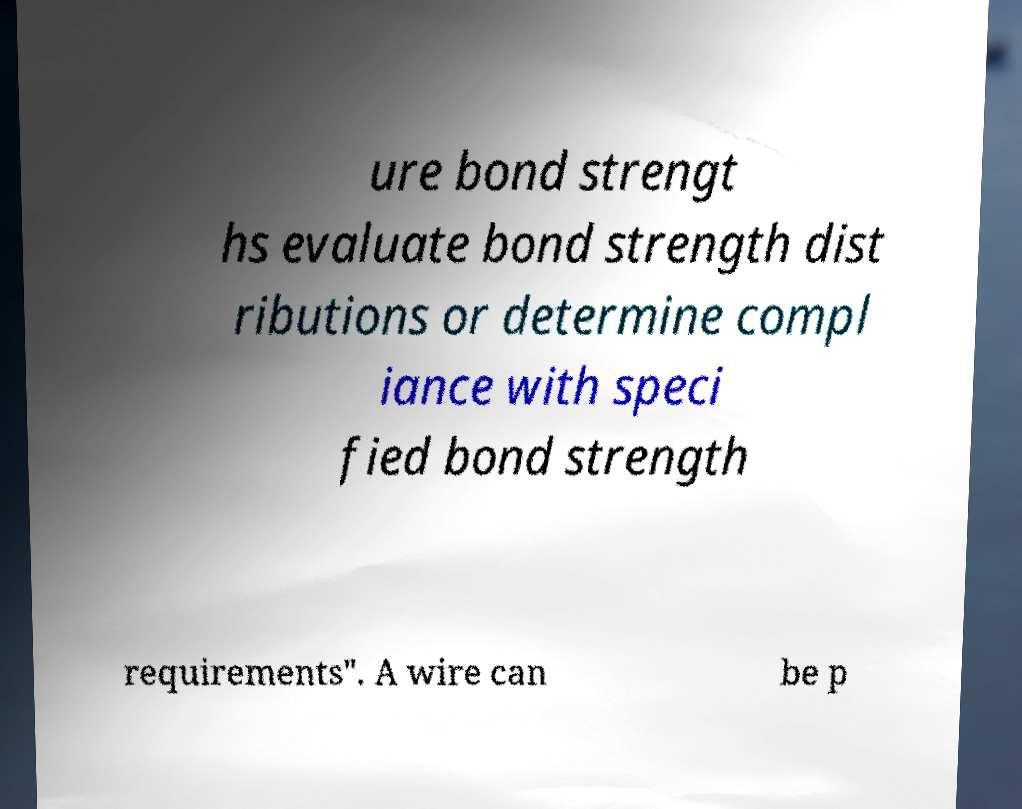Could you extract and type out the text from this image? ure bond strengt hs evaluate bond strength dist ributions or determine compl iance with speci fied bond strength requirements". A wire can be p 